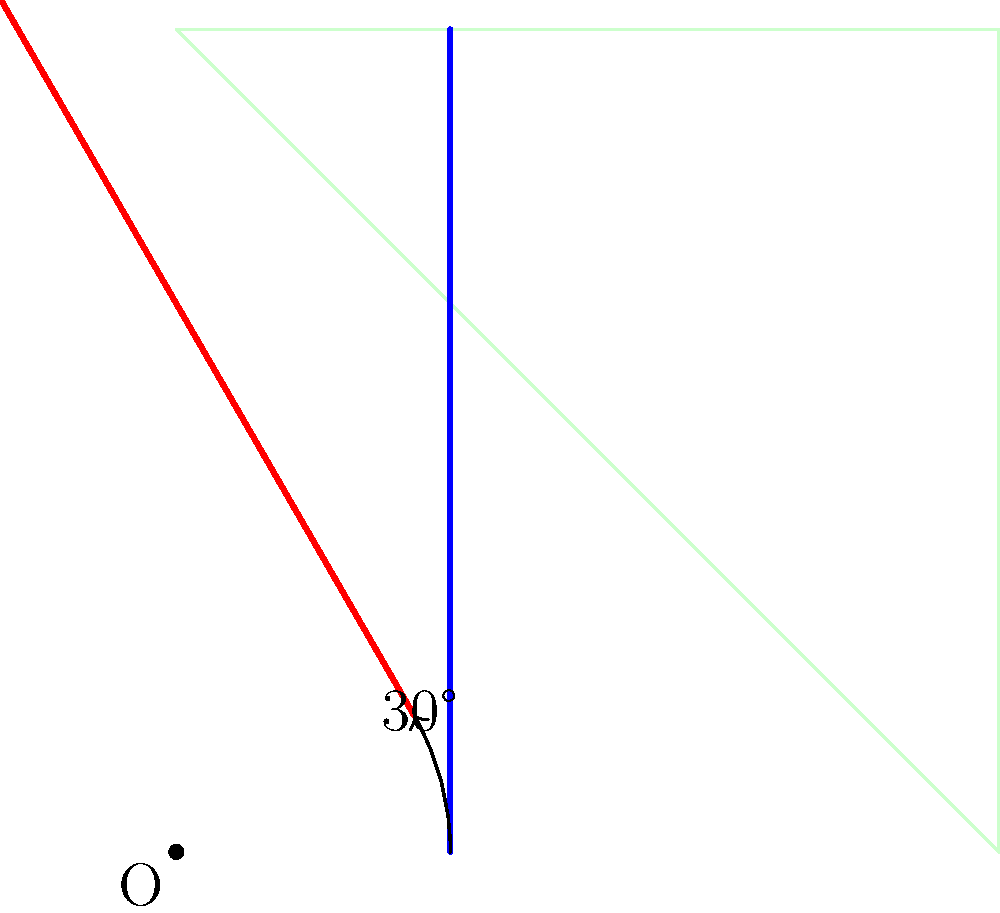A rectangular field is represented by a 3x3 unit square. A tractor's straight path is initially parallel to the y-axis, starting at coordinates (1,0) and ending at (1,3). To optimize field coverage, the path needs to be rotated 30° clockwise around the origin. What are the coordinates of the endpoint of the rotated path? To solve this problem, we'll use the rotation matrix for a 30° clockwise rotation and apply it to the endpoint of the original path.

Step 1: Identify the original endpoint coordinates.
Original endpoint: (1, 3)

Step 2: Recall the rotation matrix for a clockwise rotation by angle θ:
$$ R = \begin{bmatrix} \cos \theta & \sin \theta \\ -\sin \theta & \cos \theta \end{bmatrix} $$

Step 3: For a 30° rotation, we have:
$$ R = \begin{bmatrix} \cos 30° & \sin 30° \\ -\sin 30° & \cos 30° \end{bmatrix} = \begin{bmatrix} \frac{\sqrt{3}}{2} & \frac{1}{2} \\ -\frac{1}{2} & \frac{\sqrt{3}}{2} \end{bmatrix} $$

Step 4: Apply the rotation matrix to the endpoint coordinates:
$$ \begin{bmatrix} x' \\ y' \end{bmatrix} = \begin{bmatrix} \frac{\sqrt{3}}{2} & \frac{1}{2} \\ -\frac{1}{2} & \frac{\sqrt{3}}{2} \end{bmatrix} \begin{bmatrix} 1 \\ 3 \end{bmatrix} $$

Step 5: Multiply the matrices:
$$ \begin{bmatrix} x' \\ y' \end{bmatrix} = \begin{bmatrix} \frac{\sqrt{3}}{2} \cdot 1 + \frac{1}{2} \cdot 3 \\ -\frac{1}{2} \cdot 1 + \frac{\sqrt{3}}{2} \cdot 3 \end{bmatrix} = \begin{bmatrix} \frac{\sqrt{3}}{2} + \frac{3}{2} \\ -\frac{1}{2} + \frac{3\sqrt{3}}{2} \end{bmatrix} $$

Step 6: Simplify:
$$ x' = \frac{\sqrt{3}}{2} + \frac{3}{2} = \frac{\sqrt{3} + 3}{2} $$
$$ y' = -\frac{1}{2} + \frac{3\sqrt{3}}{2} = \frac{3\sqrt{3} - 1}{2} $$

Therefore, the coordinates of the endpoint of the rotated path are $(\frac{\sqrt{3} + 3}{2}, \frac{3\sqrt{3} - 1}{2})$.
Answer: $(\frac{\sqrt{3} + 3}{2}, \frac{3\sqrt{3} - 1}{2})$ 